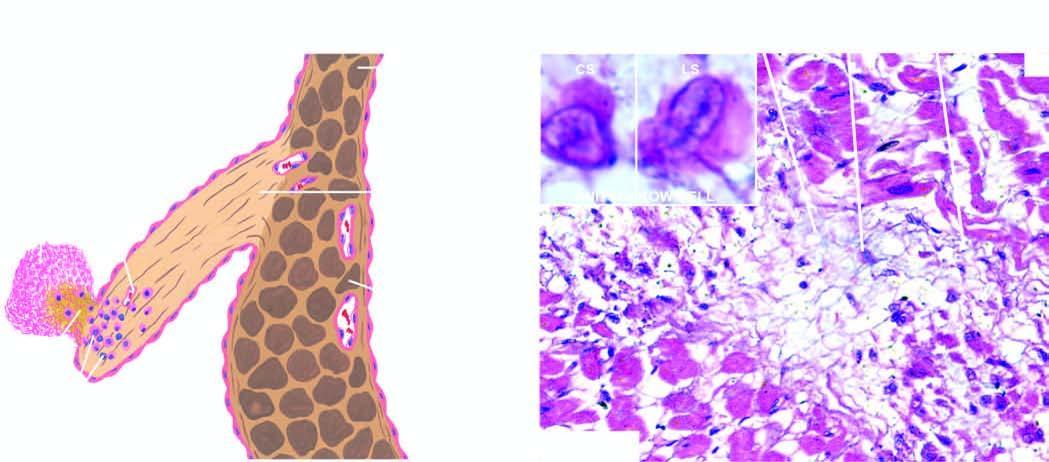does 2 and 3 show an anitschkow cell in cross section and in longitudinal section?
Answer the question using a single word or phrase. No 